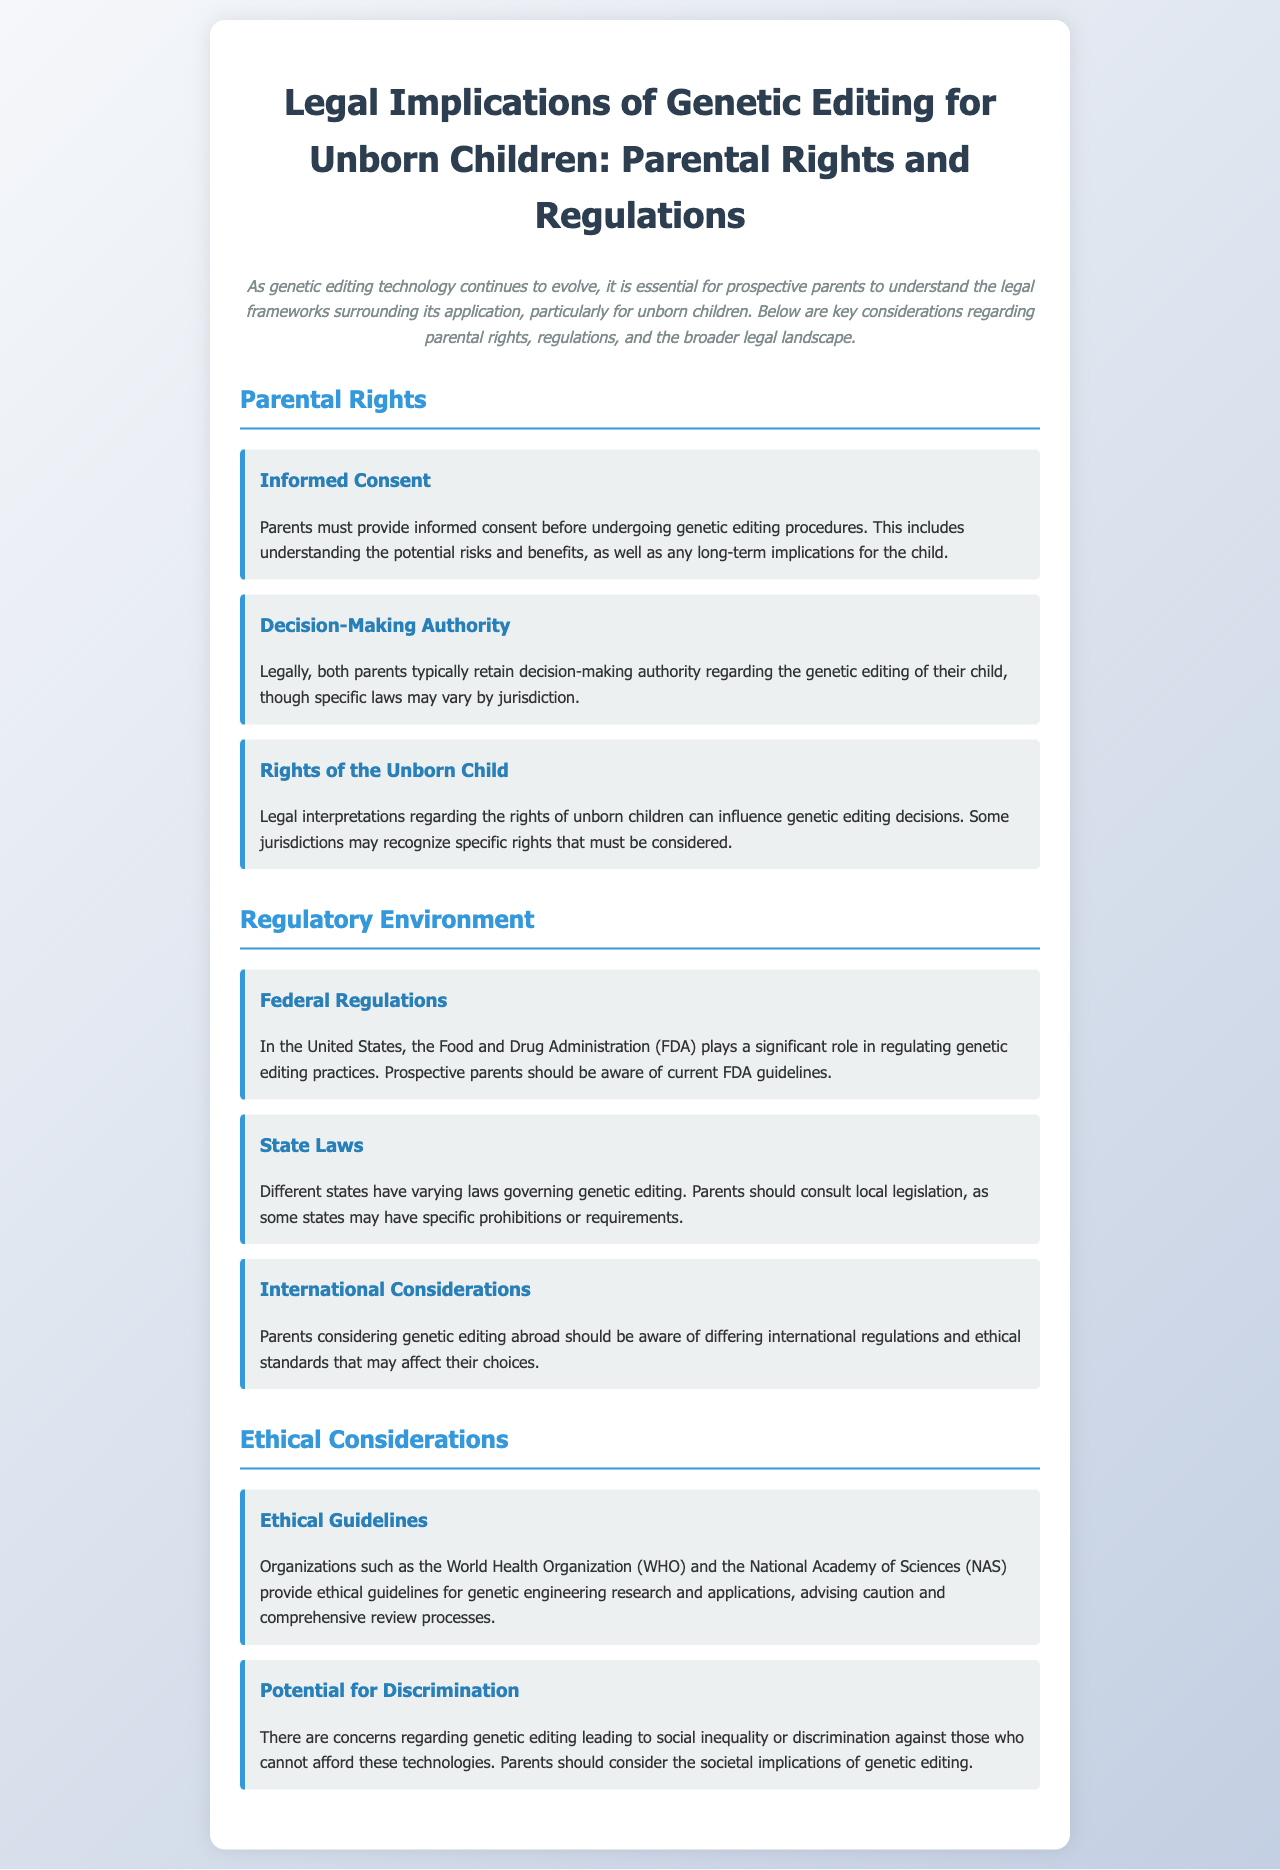What is required before undergoing genetic editing? Parents must provide informed consent before undergoing genetic editing procedures, as stated in the document.
Answer: informed consent Who typically retains decision-making authority regarding genetic editing? Both parents typically retain decision-making authority regarding the genetic editing of their child.
Answer: both parents Which U.S. agency regulates genetic editing practices? In the United States, the Food and Drug Administration (FDA) plays a significant role in regulating genetic editing practices.
Answer: FDA What should parents consult regarding genetic editing laws? Parents should consult local legislation, as some states may have specific prohibitions or requirements regarding genetic editing.
Answer: local legislation What organization provides ethical guidelines for genetic engineering? Organizations such as the World Health Organization (WHO) provide ethical guidelines for genetic engineering research and applications.
Answer: WHO What is a potential concern related to genetic editing mentioned in the document? There are concerns regarding genetic editing leading to social inequality or discrimination against those who cannot afford these technologies.
Answer: discrimination How do different states affect parental decisions on genetic editing? Different states have varying laws governing genetic editing that can influence parental decisions and responsibilities.
Answer: varying laws What is the primary focus of the document? The document focuses on the legal implications of genetic editing for unborn children, including parental rights and regulations.
Answer: legal implications 